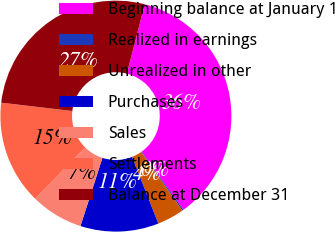Convert chart to OTSL. <chart><loc_0><loc_0><loc_500><loc_500><pie_chart><fcel>Beginning balance at January 1<fcel>Realized in earnings<fcel>Unrealized in other<fcel>Purchases<fcel>Sales<fcel>Settlements<fcel>Balance at December 31<nl><fcel>36.05%<fcel>0.18%<fcel>3.77%<fcel>10.95%<fcel>7.36%<fcel>14.54%<fcel>27.17%<nl></chart> 